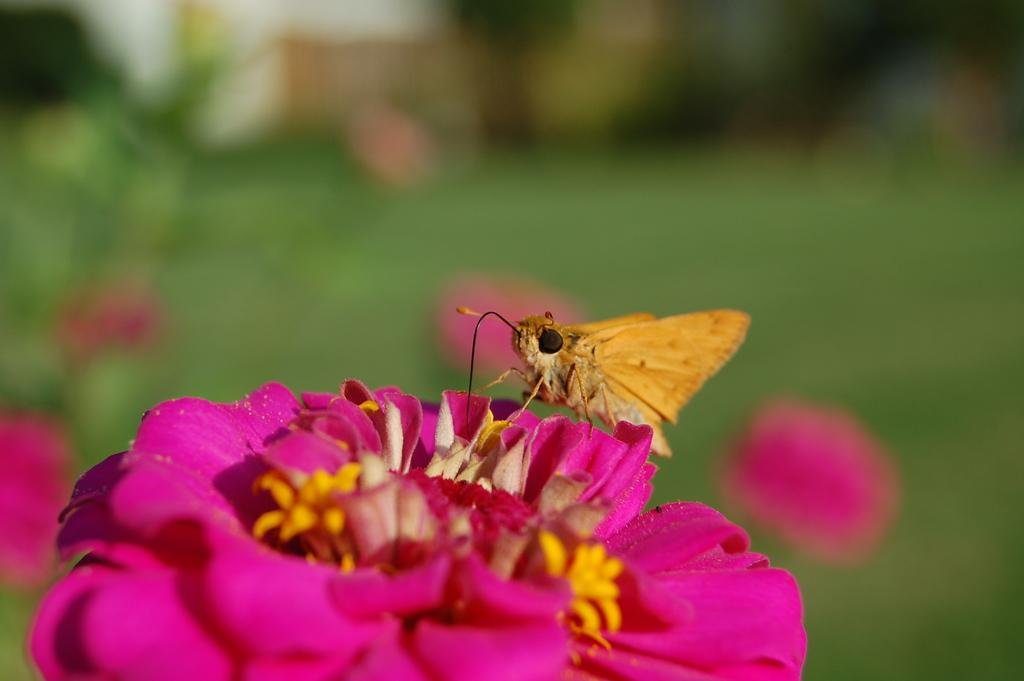What type of creature can be seen in the image? There is an insect in the image. Where is the insect located in the image? The insect is sitting on a flower. What other living organisms can be seen in the image? There are plants and flowers in the image. What type of ghost can be seen in the image? There is no ghost present in the image; it features an insect sitting on a flower. How does the lift function in the image? There is no lift present in the image. 